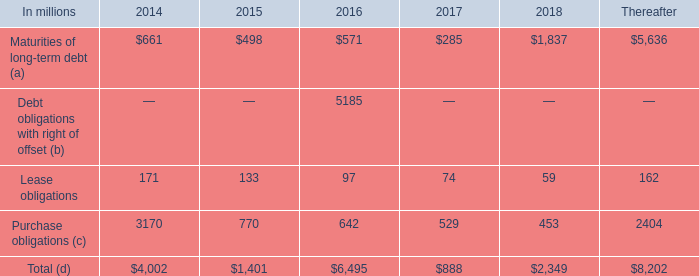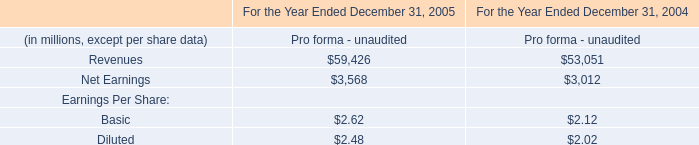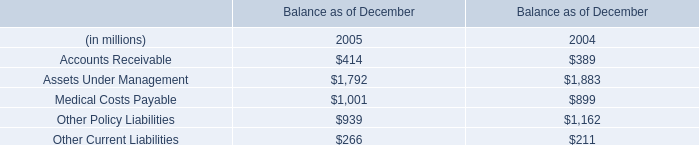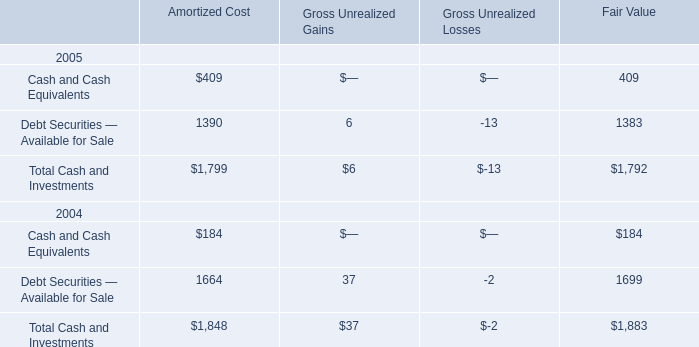Which year is the value of the Gross Unrealized Gains for Debt Securities — Available for Sale the lowest? 
Answer: 2005. 